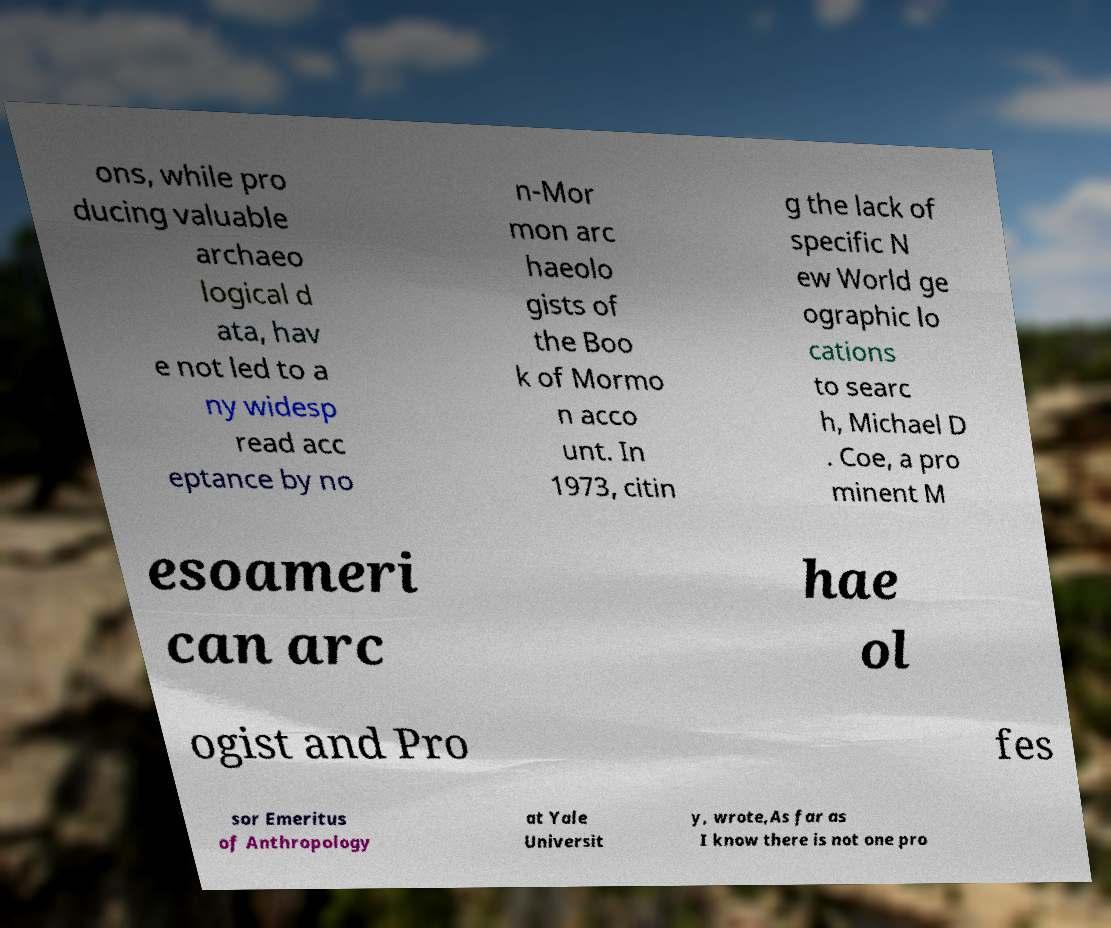Could you assist in decoding the text presented in this image and type it out clearly? ons, while pro ducing valuable archaeo logical d ata, hav e not led to a ny widesp read acc eptance by no n-Mor mon arc haeolo gists of the Boo k of Mormo n acco unt. In 1973, citin g the lack of specific N ew World ge ographic lo cations to searc h, Michael D . Coe, a pro minent M esoameri can arc hae ol ogist and Pro fes sor Emeritus of Anthropology at Yale Universit y, wrote,As far as I know there is not one pro 